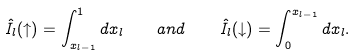Convert formula to latex. <formula><loc_0><loc_0><loc_500><loc_500>\hat { I } _ { l } ( \uparrow ) = \int _ { x _ { l - 1 } } ^ { 1 } d x _ { l } \quad a n d \quad \hat { I } _ { l } ( \downarrow ) = \int _ { 0 } ^ { x _ { l - 1 } } d x _ { l } .</formula> 